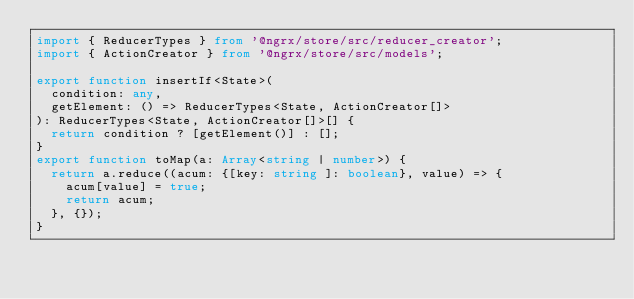<code> <loc_0><loc_0><loc_500><loc_500><_TypeScript_>import { ReducerTypes } from '@ngrx/store/src/reducer_creator';
import { ActionCreator } from '@ngrx/store/src/models';

export function insertIf<State>(
  condition: any,
  getElement: () => ReducerTypes<State, ActionCreator[]>
): ReducerTypes<State, ActionCreator[]>[] {
  return condition ? [getElement()] : [];
}
export function toMap(a: Array<string | number>) {
  return a.reduce((acum: {[key: string ]: boolean}, value) => {
    acum[value] = true;
    return acum;
  }, {});
}
</code> 